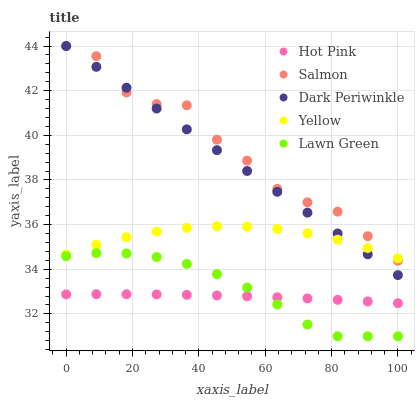Does Hot Pink have the minimum area under the curve?
Answer yes or no. Yes. Does Salmon have the maximum area under the curve?
Answer yes or no. Yes. Does Salmon have the minimum area under the curve?
Answer yes or no. No. Does Hot Pink have the maximum area under the curve?
Answer yes or no. No. Is Dark Periwinkle the smoothest?
Answer yes or no. Yes. Is Salmon the roughest?
Answer yes or no. Yes. Is Hot Pink the smoothest?
Answer yes or no. No. Is Hot Pink the roughest?
Answer yes or no. No. Does Lawn Green have the lowest value?
Answer yes or no. Yes. Does Hot Pink have the lowest value?
Answer yes or no. No. Does Dark Periwinkle have the highest value?
Answer yes or no. Yes. Does Hot Pink have the highest value?
Answer yes or no. No. Is Hot Pink less than Salmon?
Answer yes or no. Yes. Is Salmon greater than Lawn Green?
Answer yes or no. Yes. Does Hot Pink intersect Lawn Green?
Answer yes or no. Yes. Is Hot Pink less than Lawn Green?
Answer yes or no. No. Is Hot Pink greater than Lawn Green?
Answer yes or no. No. Does Hot Pink intersect Salmon?
Answer yes or no. No. 